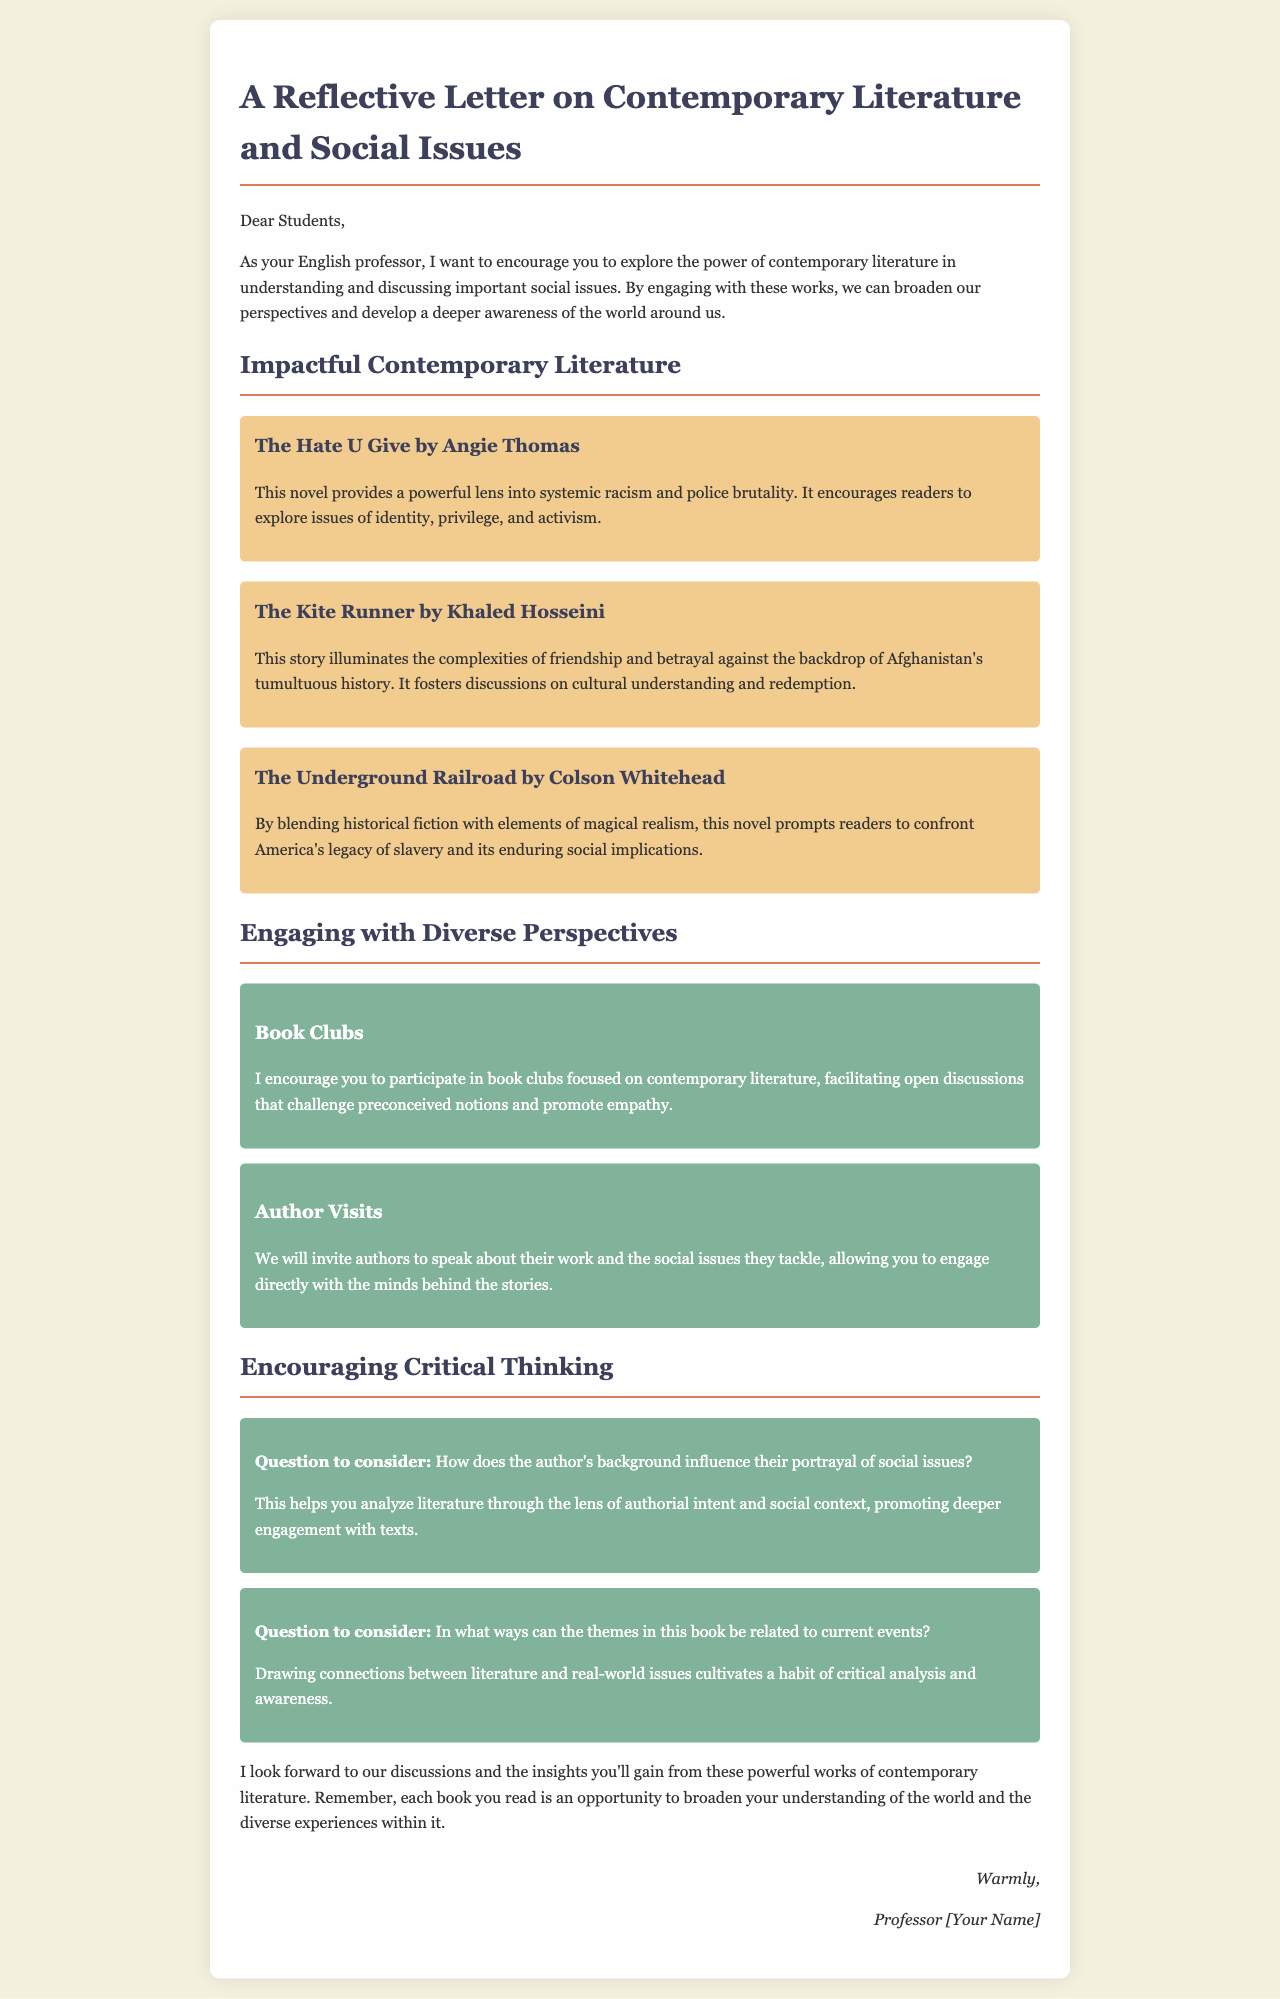What is the title of the letter? The title is prominently displayed at the top of the document as a heading.
Answer: A Reflective Letter on Contemporary Literature and Social Issues Who is the letter addressed to? The salutation indicates the recipient of the letter.
Answer: Students Name one book mentioned in the document. The document lists several books, one of which is highlighted in a separate section.
Answer: The Hate U Give What social issue does "The Underground Railroad" address? The document specifies the primary social issue explored in this book.
Answer: Slavery What strategy is suggested for engaging with contemporary literature? The letter discusses a specific method to facilitate discussions about literature.
Answer: Book Clubs How does the letter propose to enhance discussions? It mentions an approach to incorporate diverse voices into learning.
Answer: Author Visits What question is posed regarding the author's background? This question prompts critical thinking about the influences shaping the narrative.
Answer: How does the author's background influence their portrayal of social issues? What theme is encouraged to be linked to current events? This encourages readers to reflect on the relevancy of literature to contemporary issues.
Answer: Themes in this book 